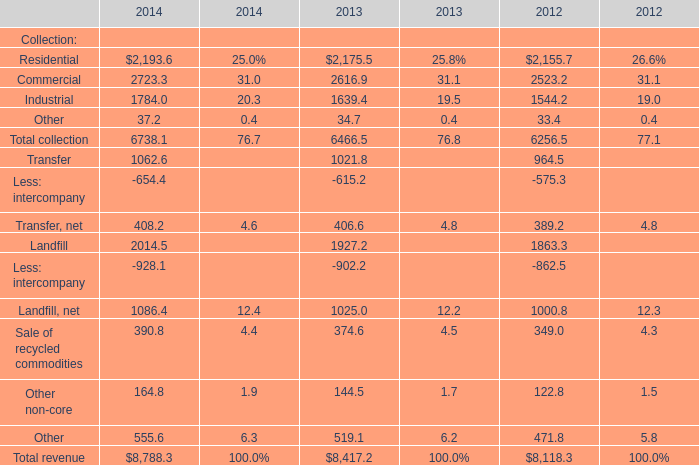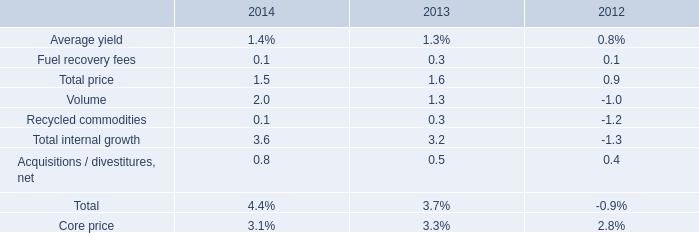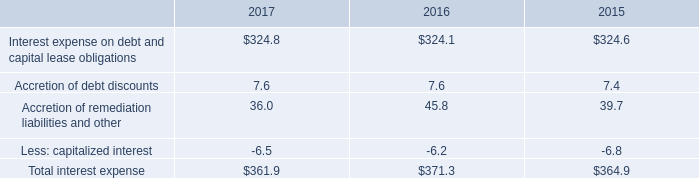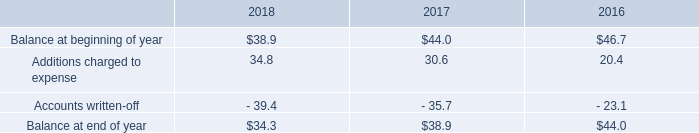as of december 312018 what was the percent of restricted cash and marketable securities dedicated to the support our insurance programs 
Computations: (78.6 / 108.1)
Answer: 0.7271. 